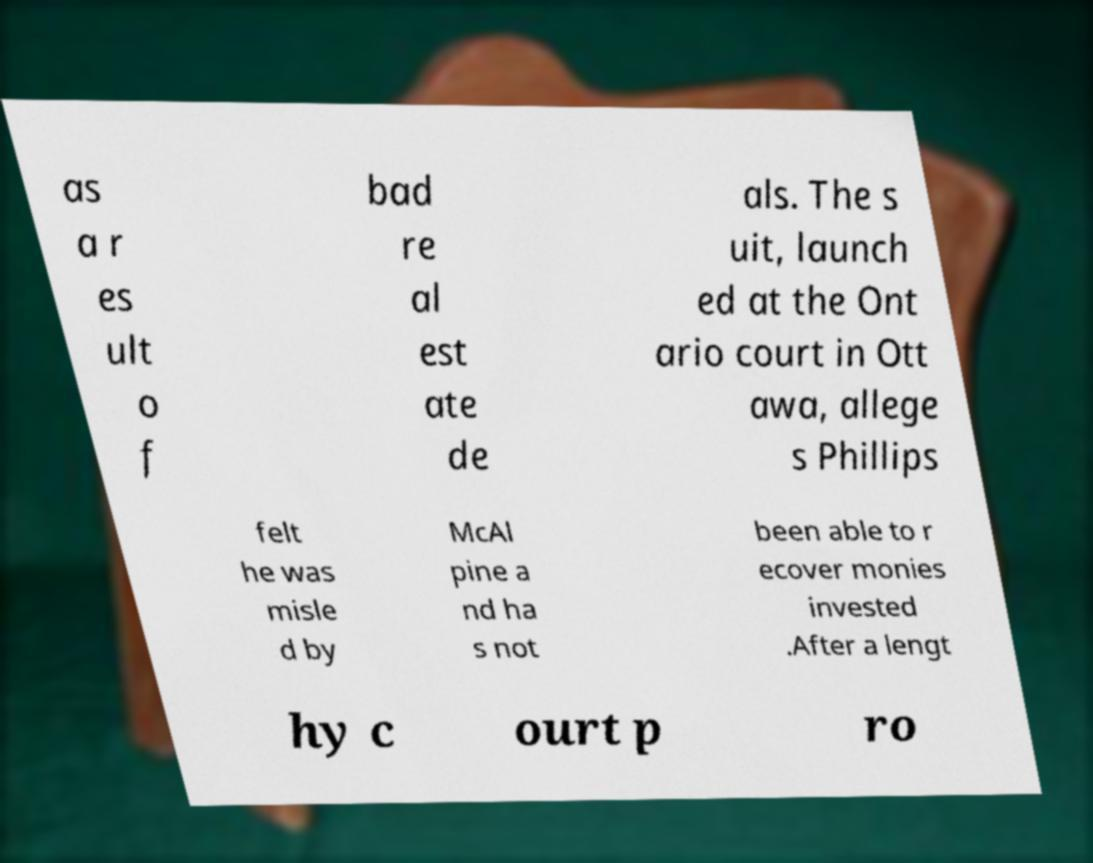Could you assist in decoding the text presented in this image and type it out clearly? as a r es ult o f bad re al est ate de als. The s uit, launch ed at the Ont ario court in Ott awa, allege s Phillips felt he was misle d by McAl pine a nd ha s not been able to r ecover monies invested .After a lengt hy c ourt p ro 